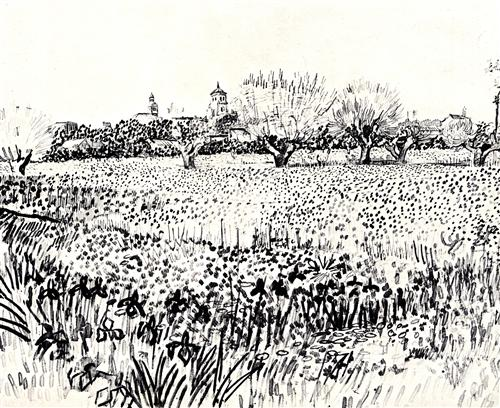If you could walk into this image and interact with the landscape, what would you do first? If I could enter this sketched landscape, I would first walk through the field of tall grasses and wildflowers, taking in their delicate fragrance and texture. I'd make my way to one of the solitary trees, feeling the roughness of its bark and perhaps lying down under its branches to gaze at the intricate patterns of the clouds overhead. I’d listen to the subtle symphony of nature, letting the peace of the scene envelop me, allowing myself to become part of the landscape's quiet, undisturbed beauty. 